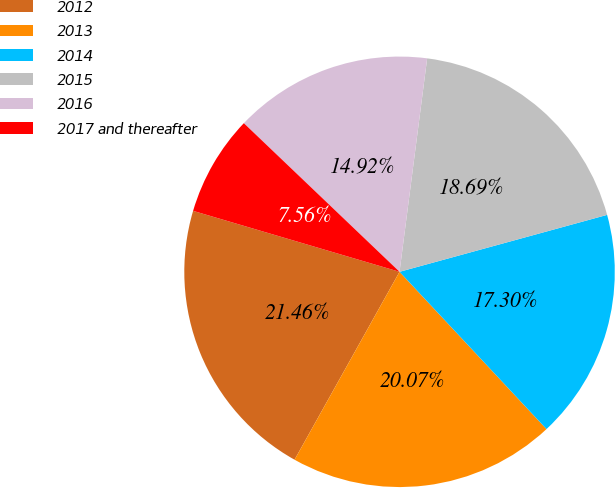Convert chart to OTSL. <chart><loc_0><loc_0><loc_500><loc_500><pie_chart><fcel>2012<fcel>2013<fcel>2014<fcel>2015<fcel>2016<fcel>2017 and thereafter<nl><fcel>21.46%<fcel>20.07%<fcel>17.3%<fcel>18.69%<fcel>14.92%<fcel>7.56%<nl></chart> 